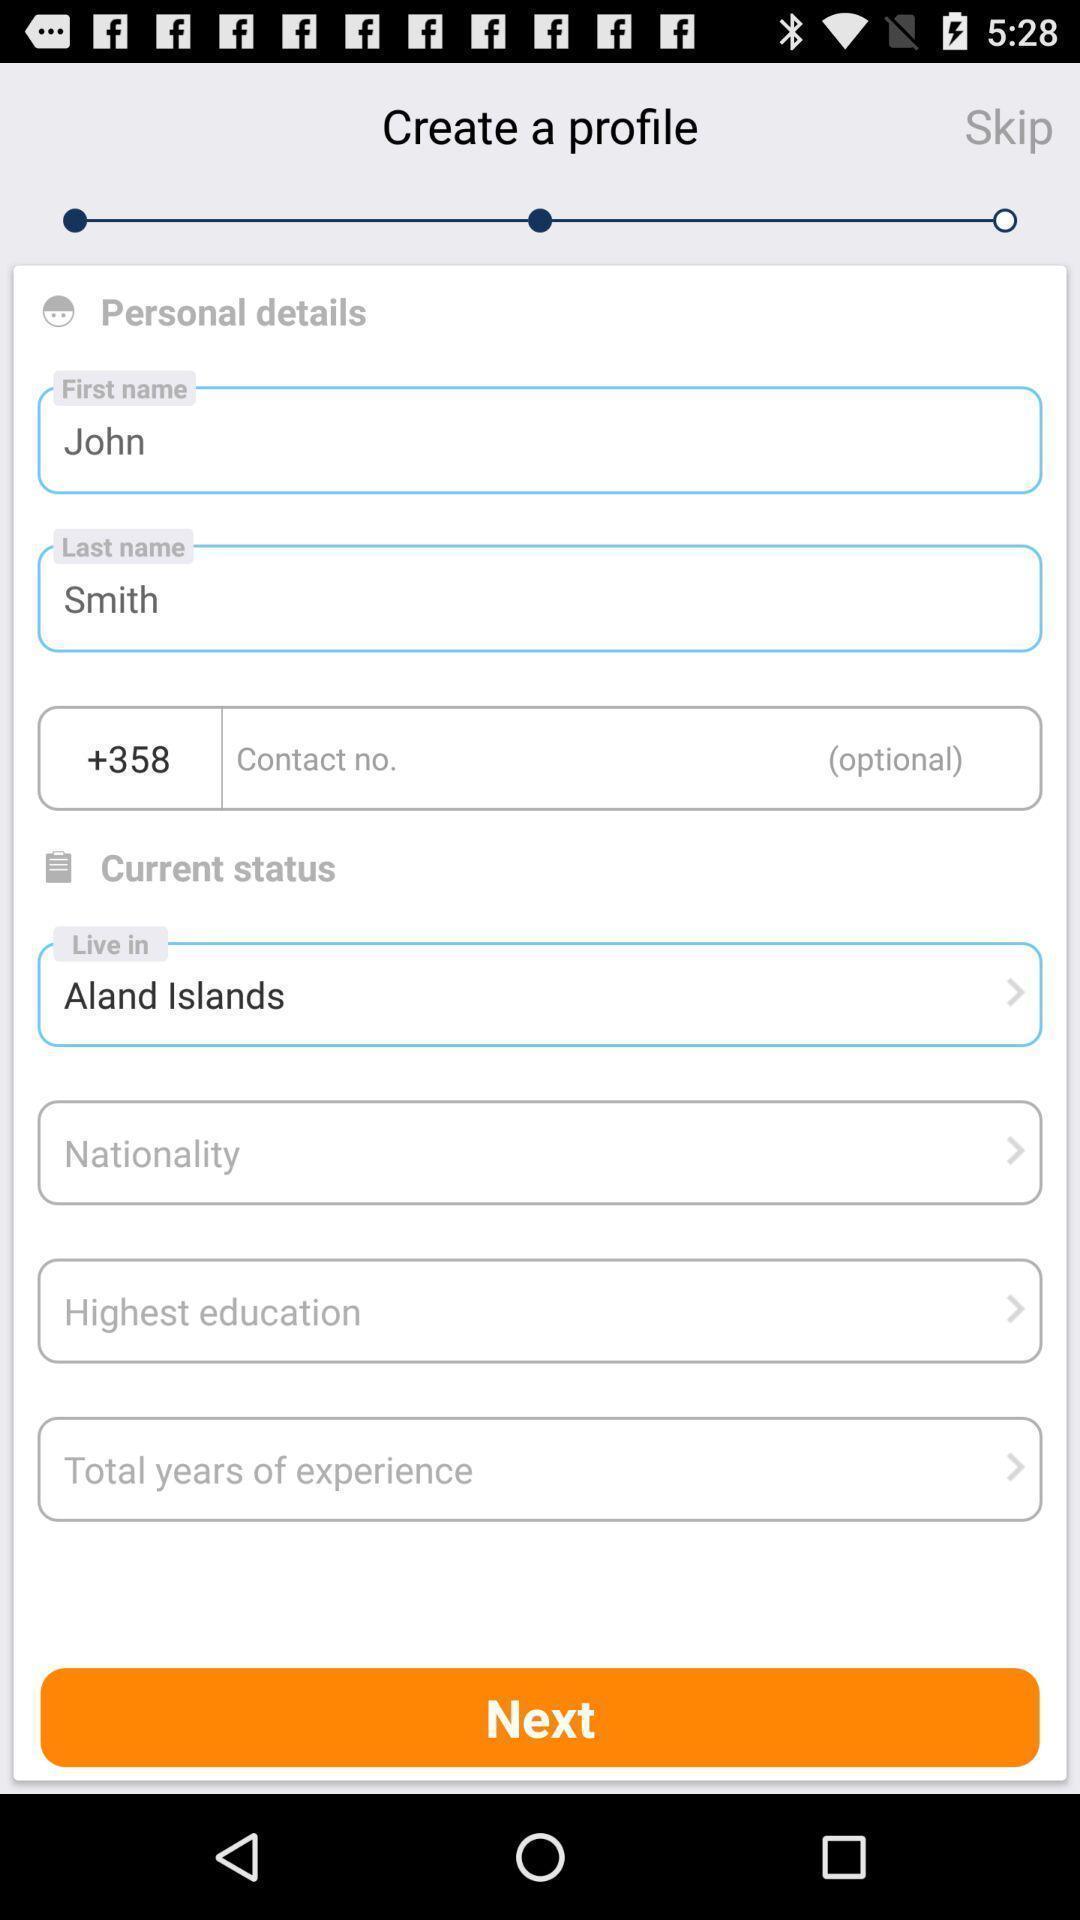Provide a textual representation of this image. Screen shows create profile with multiple options in career app. 